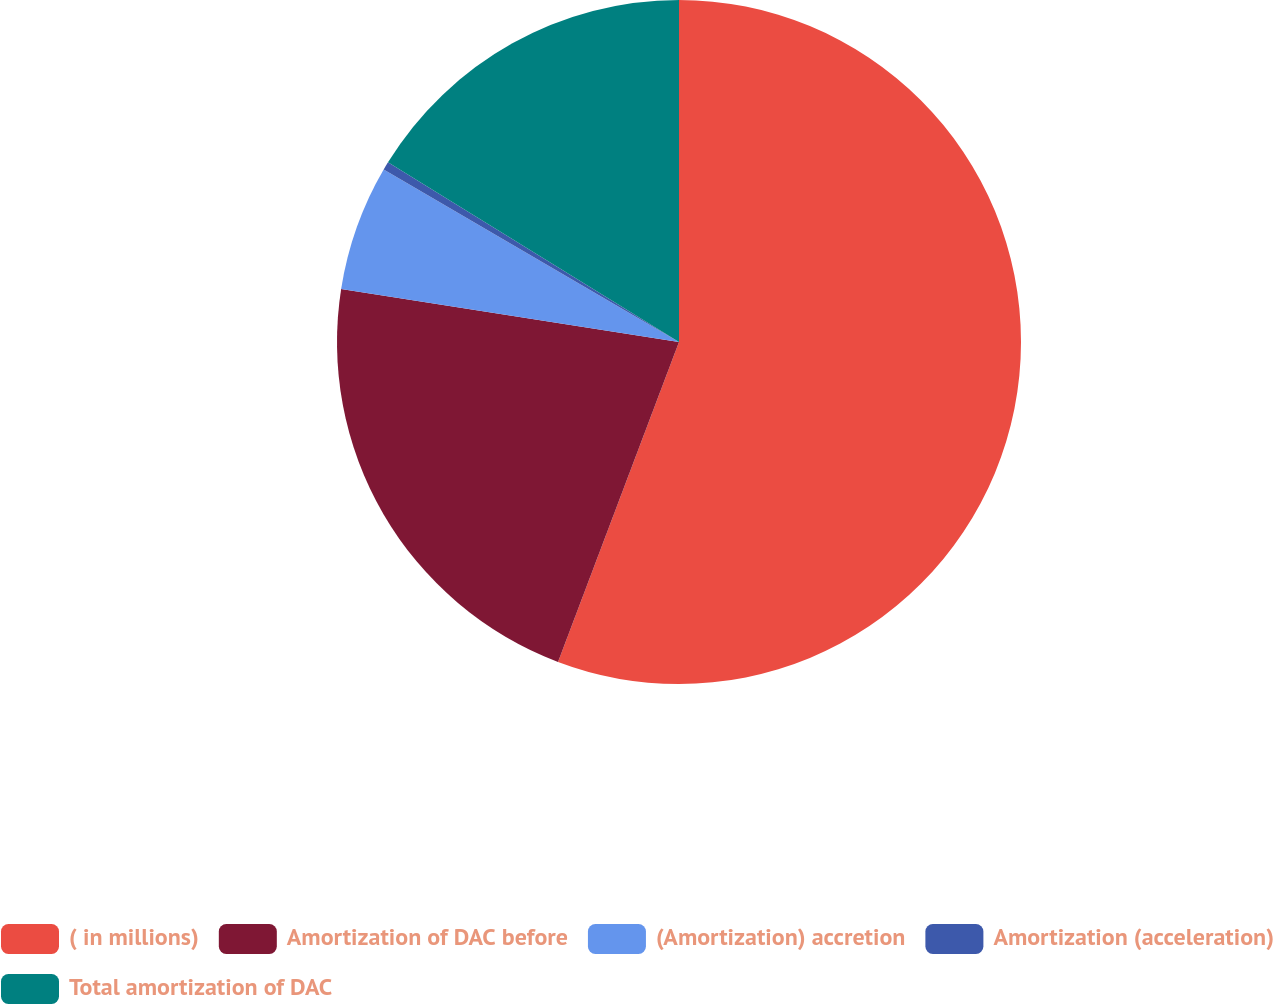Convert chart. <chart><loc_0><loc_0><loc_500><loc_500><pie_chart><fcel>( in millions)<fcel>Amortization of DAC before<fcel>(Amortization) accretion<fcel>Amortization (acceleration)<fcel>Total amortization of DAC<nl><fcel>55.76%<fcel>21.73%<fcel>5.93%<fcel>0.39%<fcel>16.2%<nl></chart> 